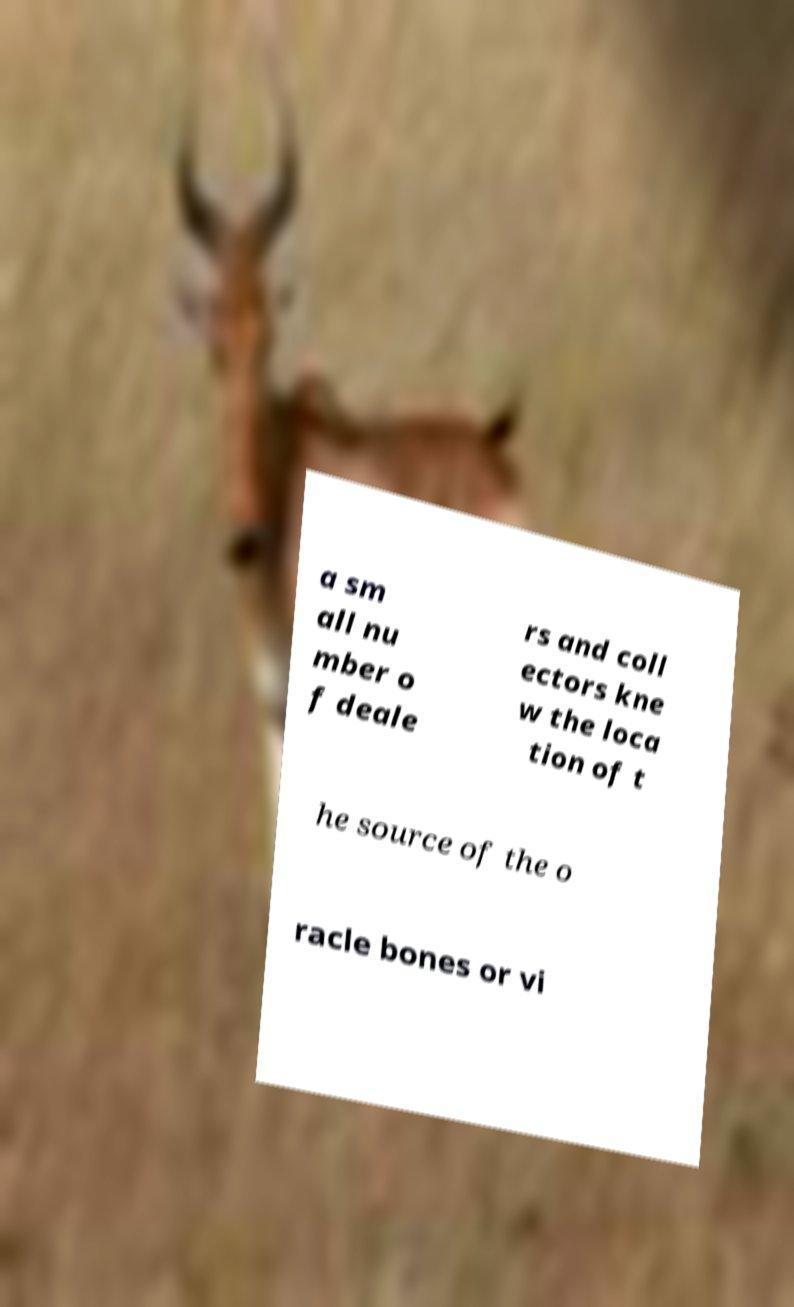There's text embedded in this image that I need extracted. Can you transcribe it verbatim? a sm all nu mber o f deale rs and coll ectors kne w the loca tion of t he source of the o racle bones or vi 